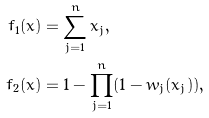<formula> <loc_0><loc_0><loc_500><loc_500>f _ { 1 } ( x ) & = \sum _ { j = 1 } ^ { n } x _ { j } , \\ f _ { 2 } ( x ) & = 1 - \prod _ { j = 1 } ^ { n } ( 1 - w _ { j } ( x _ { j } ) ) ,</formula> 